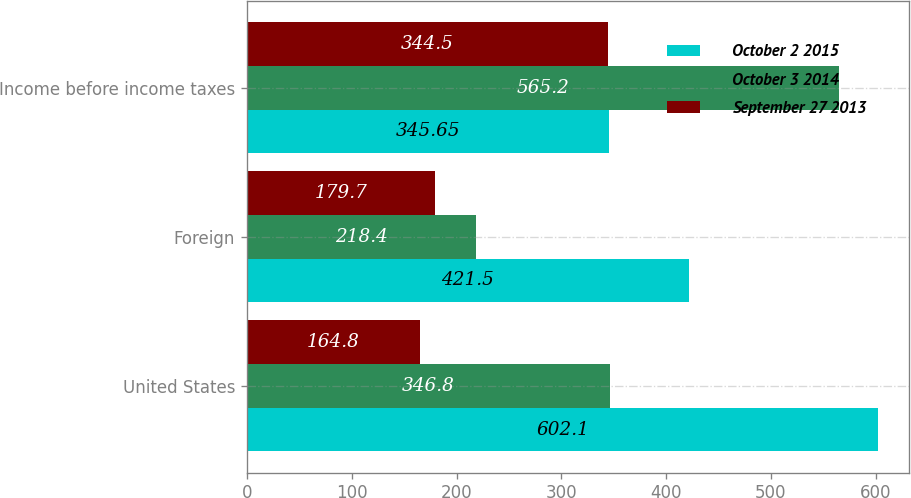<chart> <loc_0><loc_0><loc_500><loc_500><stacked_bar_chart><ecel><fcel>United States<fcel>Foreign<fcel>Income before income taxes<nl><fcel>October 2 2015<fcel>602.1<fcel>421.5<fcel>345.65<nl><fcel>October 3 2014<fcel>346.8<fcel>218.4<fcel>565.2<nl><fcel>September 27 2013<fcel>164.8<fcel>179.7<fcel>344.5<nl></chart> 